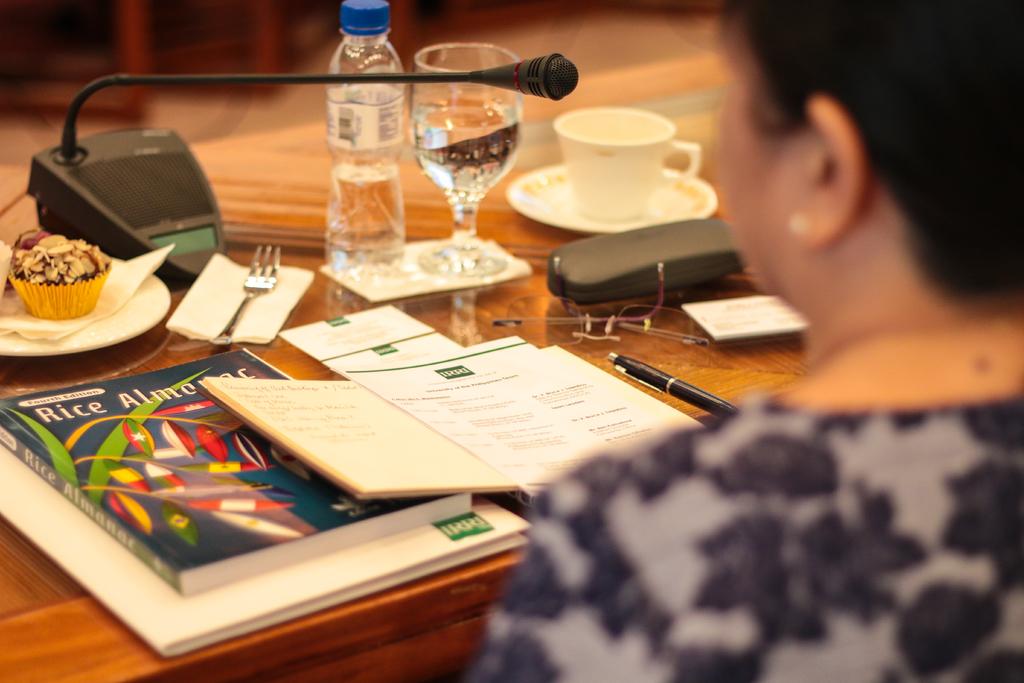What type of almanac does it say it is?
Give a very brief answer. Rice. 